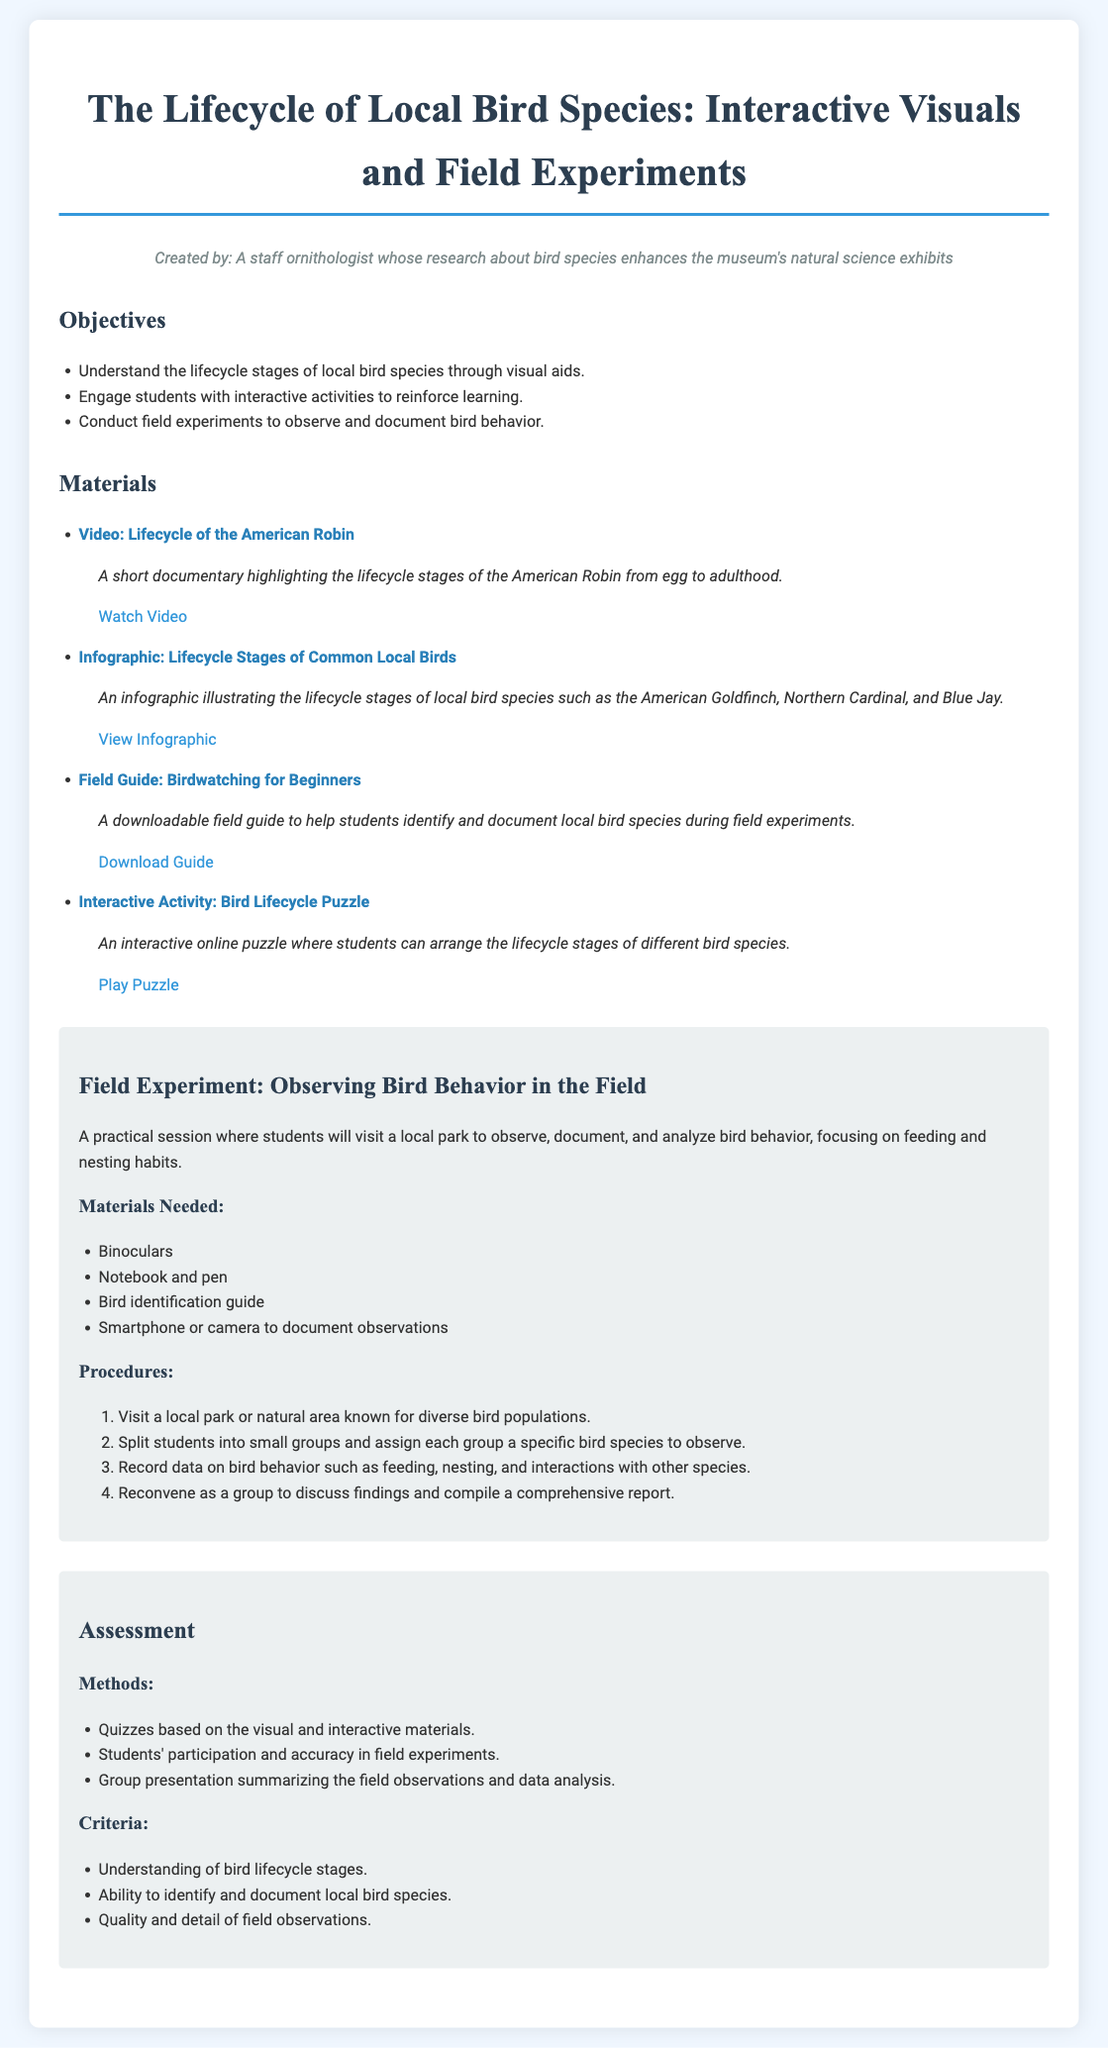What is the title of the lesson plan? The title of the lesson plan is stated at the beginning of the document.
Answer: The Lifecycle of Local Bird Species: Interactive Visuals and Field Experiments Who created the lesson plan? The creator of the lesson plan is mentioned in the persona section.
Answer: A staff ornithologist What is one objective of the lesson plan? The objectives are listed in a bulleted format, one objective can be selected from this list.
Answer: Understand the lifecycle stages of local bird species through visual aids How many materials are listed in the document? The number of materials can be determined by counting each item in the materials section.
Answer: Four What type of bird is featured in the lifecycle video? The specific bird type highlighted in the video is mentioned in the materials section.
Answer: American Robin Which interactive activity is included in the materials? An interactive activity is listed along with its description in the materials section.
Answer: Bird Lifecycle Puzzle What is the focus of the field experiment? The focus of the field experiment is emphasized in the description of that section.
Answer: Observing bird behavior What is one method of assessment mentioned in the document? Assessment methods are listed in the assessment section, from which one can be identified.
Answer: Quizzes based on the visual and interactive materials What is the procedure for documenting observations during the field experiment? The procedures outline specific steps in the field experiment section, one can be selected.
Answer: Record data on bird behavior such as feeding, nesting, and interactions with other species 